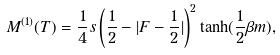Convert formula to latex. <formula><loc_0><loc_0><loc_500><loc_500>M ^ { ( 1 ) } ( T ) = \frac { 1 } { 4 } s \left ( \frac { 1 } { 2 } - | F - \frac { 1 } { 2 } | \right ) ^ { 2 } \tanh ( \frac { 1 } { 2 } \beta m ) ,</formula> 